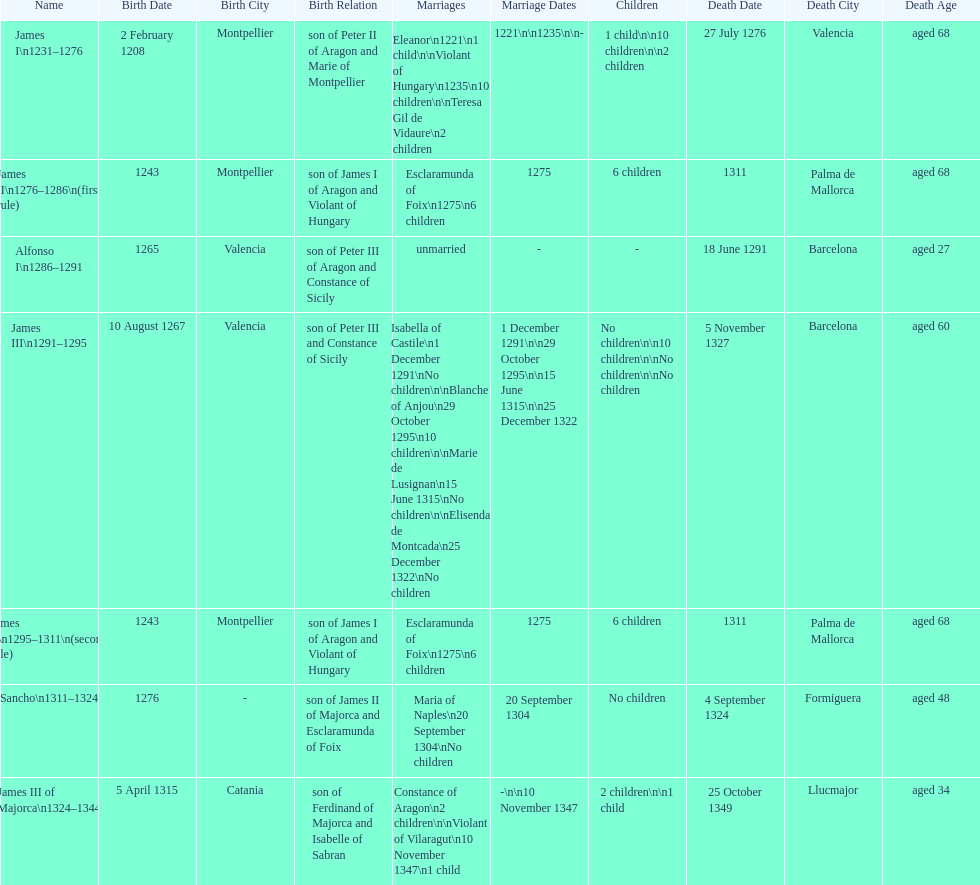Which two monarchs had no children? Alfonso I, Sancho. 